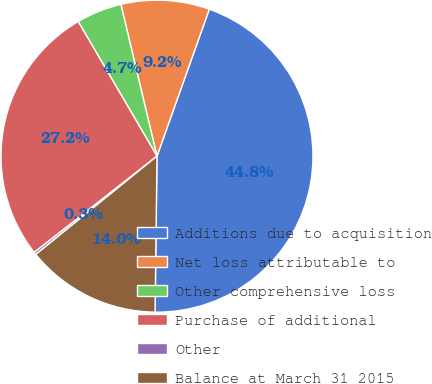<chart> <loc_0><loc_0><loc_500><loc_500><pie_chart><fcel>Additions due to acquisition<fcel>Net loss attributable to<fcel>Other comprehensive loss<fcel>Purchase of additional<fcel>Other<fcel>Balance at March 31 2015<nl><fcel>44.75%<fcel>9.16%<fcel>4.71%<fcel>27.16%<fcel>0.26%<fcel>13.96%<nl></chart> 